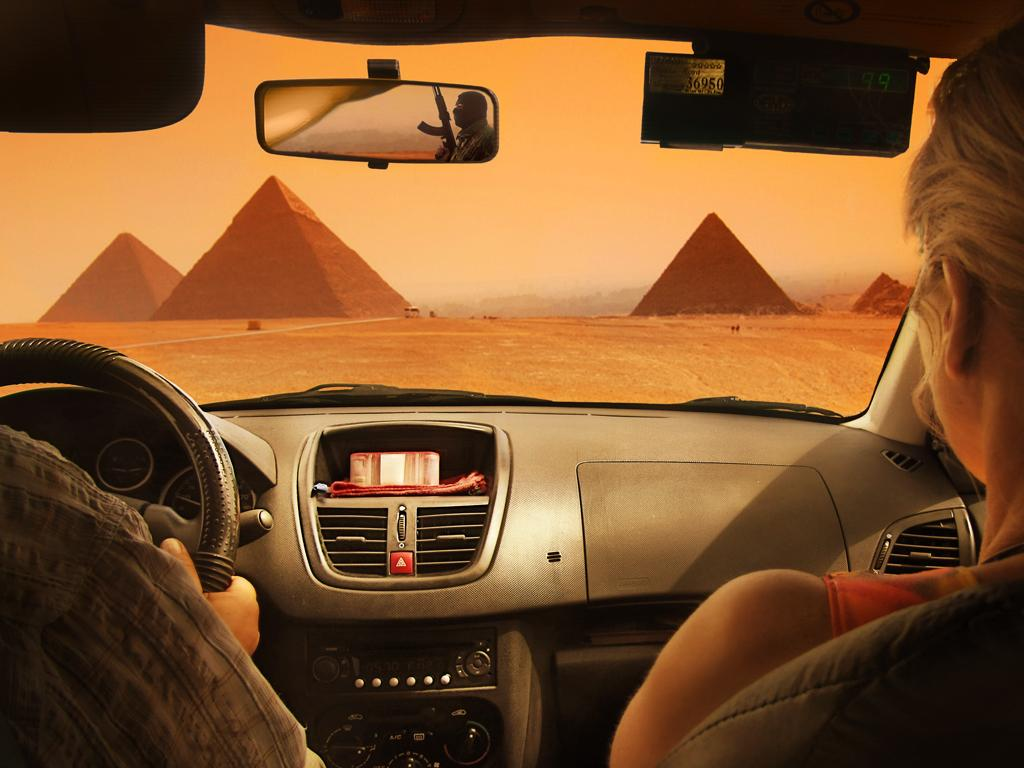What type of setting is depicted in the image? The image shows an inside view of a vehicle. How many people are present in the vehicle? There are two persons sitting in the vehicle. What is used to control the direction of the vehicle? The vehicle has a steering wheel. What type of landmarks can be seen in the background of the image? There are pyramids visible in the background of the image. What type of rabbits can be seen hopping around in the vehicle? There are no rabbits present in the vehicle; the image shows two persons sitting inside. 